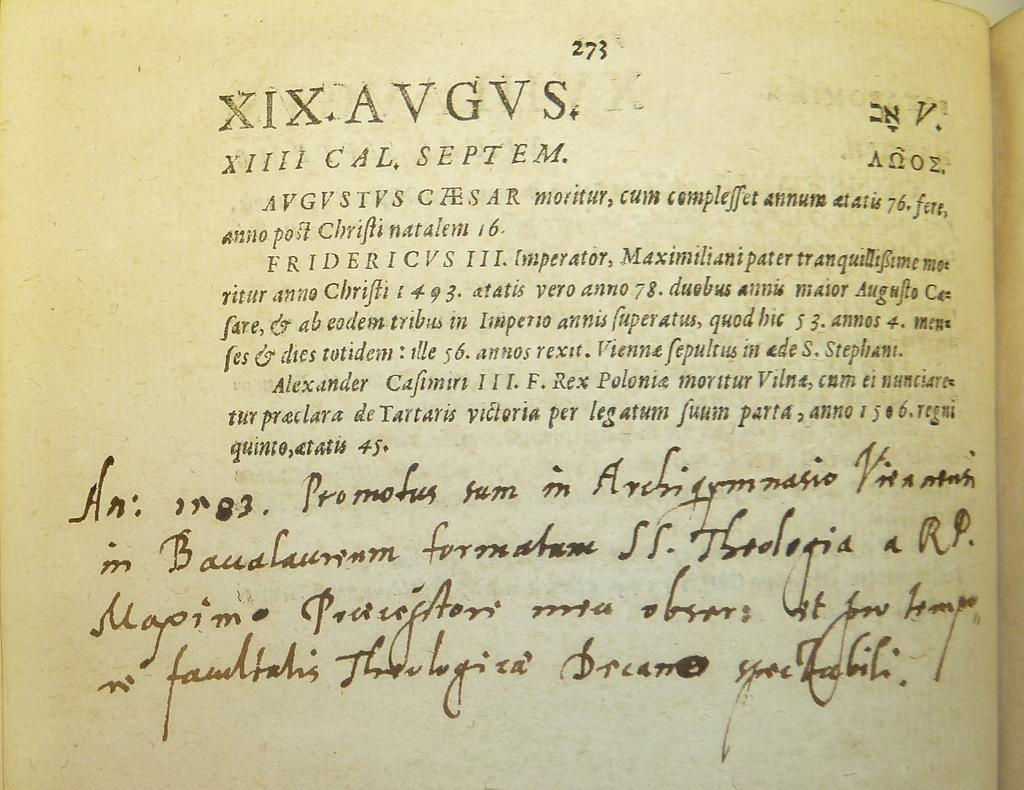<image>
Share a concise interpretation of the image provided. Book that includes roman numerals and a paragraph with a letter at the bottom 